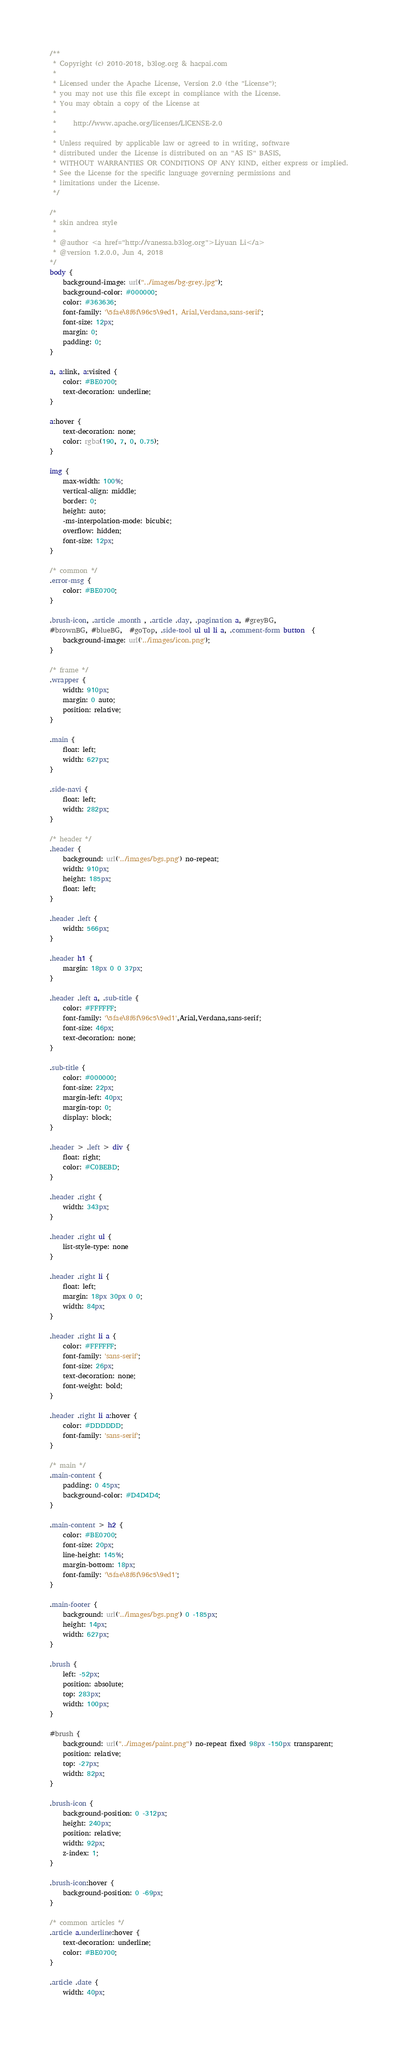Convert code to text. <code><loc_0><loc_0><loc_500><loc_500><_CSS_>/**
 * Copyright (c) 2010-2018, b3log.org & hacpai.com
 *
 * Licensed under the Apache License, Version 2.0 (the "License");
 * you may not use this file except in compliance with the License.
 * You may obtain a copy of the License at
 *
 *     http://www.apache.org/licenses/LICENSE-2.0
 *
 * Unless required by applicable law or agreed to in writing, software
 * distributed under the License is distributed on an "AS IS" BASIS,
 * WITHOUT WARRANTIES OR CONDITIONS OF ANY KIND, either express or implied.
 * See the License for the specific language governing permissions and
 * limitations under the License.
 */

/*
 * skin andrea style
 *
 * @author <a href="http://vanessa.b3log.org">Liyuan Li</a>
 * @version 1.2.0.0, Jun 4, 2018
*/
body {
    background-image: url("../images/bg-grey.jpg");
    background-color: #000000;
    color: #363636;
    font-family: '\5fae\8f6f\96c5\9ed1, Arial,Verdana,sans-serif';
    font-size: 12px;
    margin: 0;
    padding: 0;
}

a, a:link, a:visited {
    color: #BE0700;
    text-decoration: underline;
}

a:hover {
    text-decoration: none;
    color: rgba(190, 7, 0, 0.75);
}

img {
    max-width: 100%;
    vertical-align: middle;
    border: 0;
    height: auto;
    -ms-interpolation-mode: bicubic;
    overflow: hidden;
    font-size: 12px;
}

/* common */
.error-msg {
    color: #BE0700;
}

.brush-icon, .article .month , .article .day, .pagination a, #greyBG,
#brownBG, #blueBG,  #goTop, .side-tool ul ul li a, .comment-form button  {
    background-image: url('../images/icon.png');
}

/* frame */
.wrapper {
    width: 910px;
    margin: 0 auto;
    position: relative;
}

.main {
    float: left;
    width: 627px;
}

.side-navi {
    float: left;
    width: 282px;
}

/* header */
.header {
    background: url('../images/bgs.png') no-repeat;
    width: 910px;
    height: 185px;
    float: left;
}

.header .left {
    width: 566px;
}

.header h1 {
    margin: 18px 0 0 37px;
}

.header .left a, .sub-title {
    color: #FFFFFF;
    font-family: '\5fae\8f6f\96c5\9ed1',Arial,Verdana,sans-serif;
    font-size: 46px;
    text-decoration: none;
}

.sub-title {
    color: #000000;
    font-size: 22px;
    margin-left: 40px;
    margin-top: 0;
    display: block;
}

.header > .left > div {
    float: right;
    color: #C0BEBD;
}

.header .right {
    width: 343px;
}

.header .right ul {
    list-style-type: none
}

.header .right li {
    float: left;
    margin: 18px 30px 0 0;
    width: 84px;
}

.header .right li a {
    color: #FFFFFF;
    font-family: 'sans-serif';
    font-size: 26px;
    text-decoration: none;
    font-weight: bold;
}

.header .right li a:hover {
    color: #DDDDDD;
    font-family: 'sans-serif';
}

/* main */
.main-content {
    padding: 0 45px;
    background-color: #D4D4D4;
}

.main-content > h2 {
    color: #BE0700;
    font-size: 20px;
    line-height: 145%;
    margin-bottom: 18px;
    font-family: '\5fae\8f6f\96c5\9ed1';
}

.main-footer {
    background: url('../images/bgs.png') 0 -185px;
    height: 14px;
    width: 627px;
}

.brush {
    left: -52px;
    position: absolute;
    top: 283px;
    width: 100px;
}

#brush {
    background: url("../images/paint.png") no-repeat fixed 98px -150px transparent;
    position: relative;
    top: -27px;
    width: 82px;
}

.brush-icon {
    background-position: 0 -312px;
    height: 240px;
    position: relative;
    width: 92px;
    z-index: 1;
}

.brush-icon:hover {
    background-position: 0 -69px;
}

/* common articles */
.article a.underline:hover {
    text-decoration: underline;
    color: #BE0700;
}

.article .date {
    width: 40px;</code> 